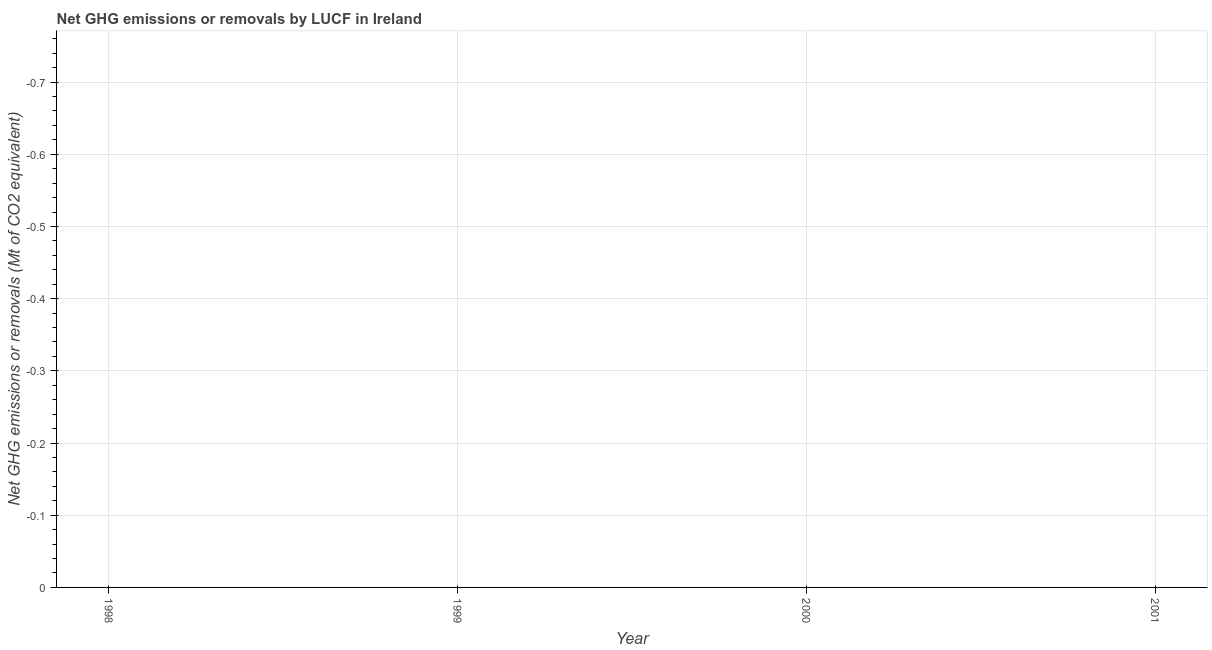What is the average ghg net emissions or removals per year?
Offer a very short reply. 0. Does the ghg net emissions or removals monotonically increase over the years?
Give a very brief answer. No. How many years are there in the graph?
Offer a very short reply. 4. What is the difference between two consecutive major ticks on the Y-axis?
Ensure brevity in your answer.  0.1. Are the values on the major ticks of Y-axis written in scientific E-notation?
Provide a succinct answer. No. Does the graph contain grids?
Your answer should be very brief. Yes. What is the title of the graph?
Make the answer very short. Net GHG emissions or removals by LUCF in Ireland. What is the label or title of the Y-axis?
Keep it short and to the point. Net GHG emissions or removals (Mt of CO2 equivalent). What is the Net GHG emissions or removals (Mt of CO2 equivalent) in 1998?
Your response must be concise. 0. What is the Net GHG emissions or removals (Mt of CO2 equivalent) in 2001?
Keep it short and to the point. 0. 